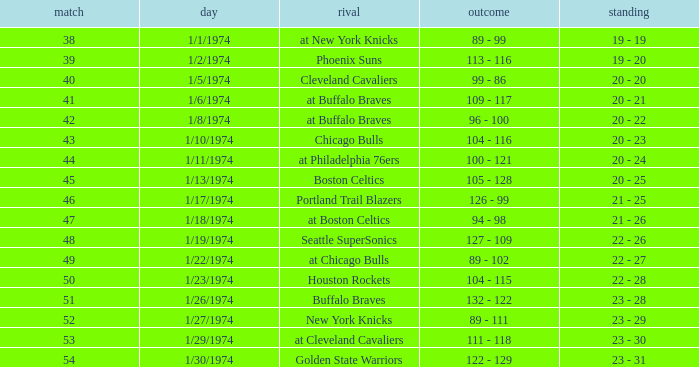What was the record after game 51 on 1/27/1974? 23 - 29. 